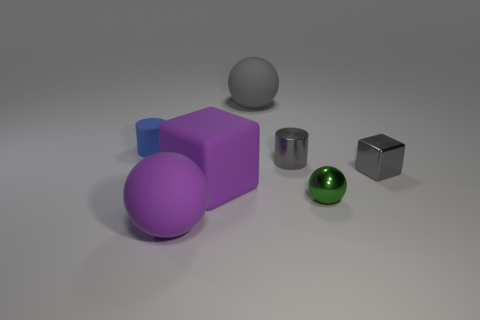Subtract all big matte spheres. How many spheres are left? 1 Subtract all cubes. How many objects are left? 5 Subtract 1 cylinders. How many cylinders are left? 1 Add 3 tiny gray objects. How many objects exist? 10 Subtract all gray balls. How many balls are left? 2 Subtract all yellow spheres. How many green cylinders are left? 0 Subtract all big gray rubber balls. Subtract all shiny cylinders. How many objects are left? 5 Add 7 blue objects. How many blue objects are left? 8 Add 6 small blue rubber things. How many small blue rubber things exist? 7 Subtract 0 red cubes. How many objects are left? 7 